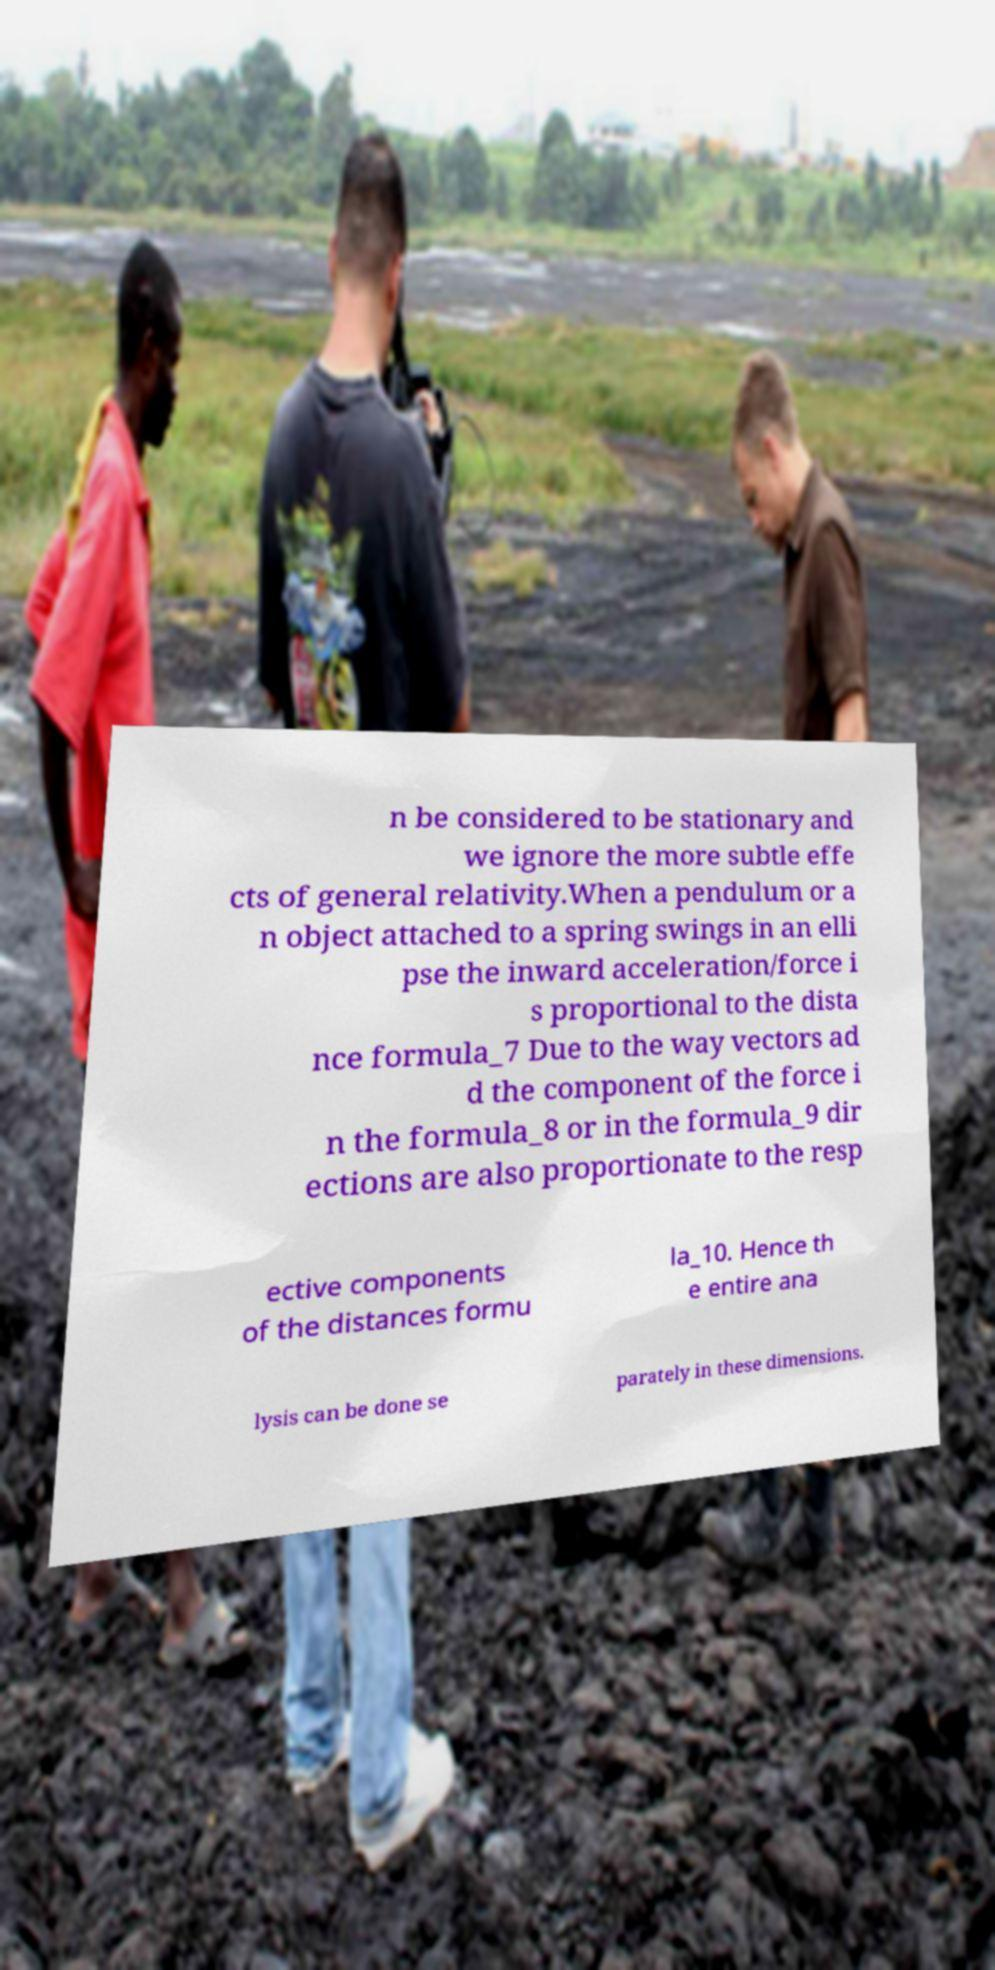Please read and relay the text visible in this image. What does it say? n be considered to be stationary and we ignore the more subtle effe cts of general relativity.When a pendulum or a n object attached to a spring swings in an elli pse the inward acceleration/force i s proportional to the dista nce formula_7 Due to the way vectors ad d the component of the force i n the formula_8 or in the formula_9 dir ections are also proportionate to the resp ective components of the distances formu la_10. Hence th e entire ana lysis can be done se parately in these dimensions. 